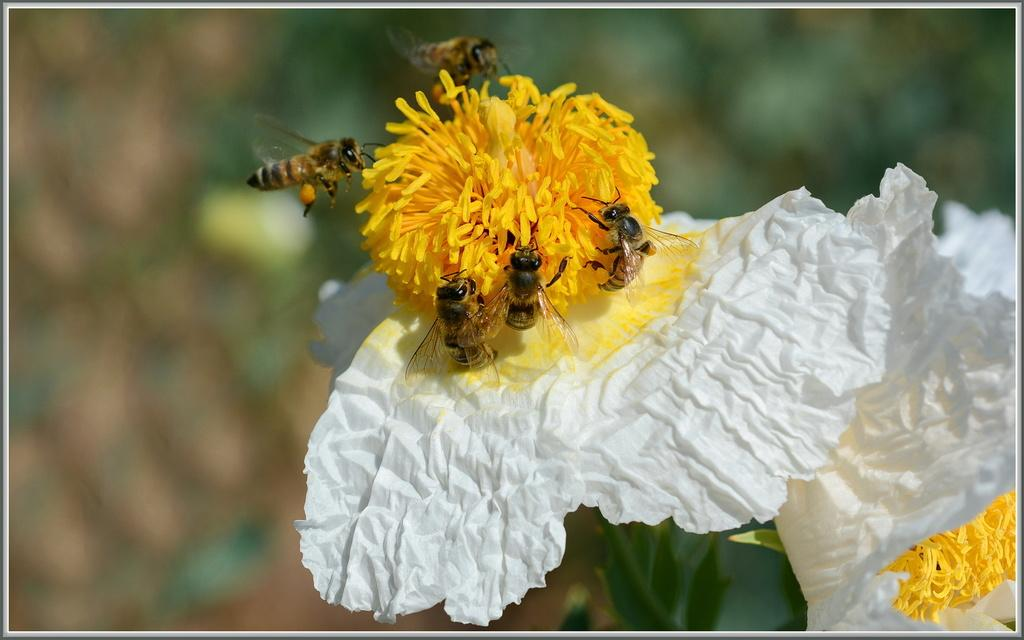What colors are the flowers in the image? The flowers in the image are white and yellow. How many honey bees can be seen in the image? Five honey bees are sitting on the flowers in the image. Can you describe the background of the image? The background of the image is blurred. What is the quietest time of day for the flowers in the image? The provided facts do not mention the time of day or the noise level of the flowers, so it is not possible to answer this question. 